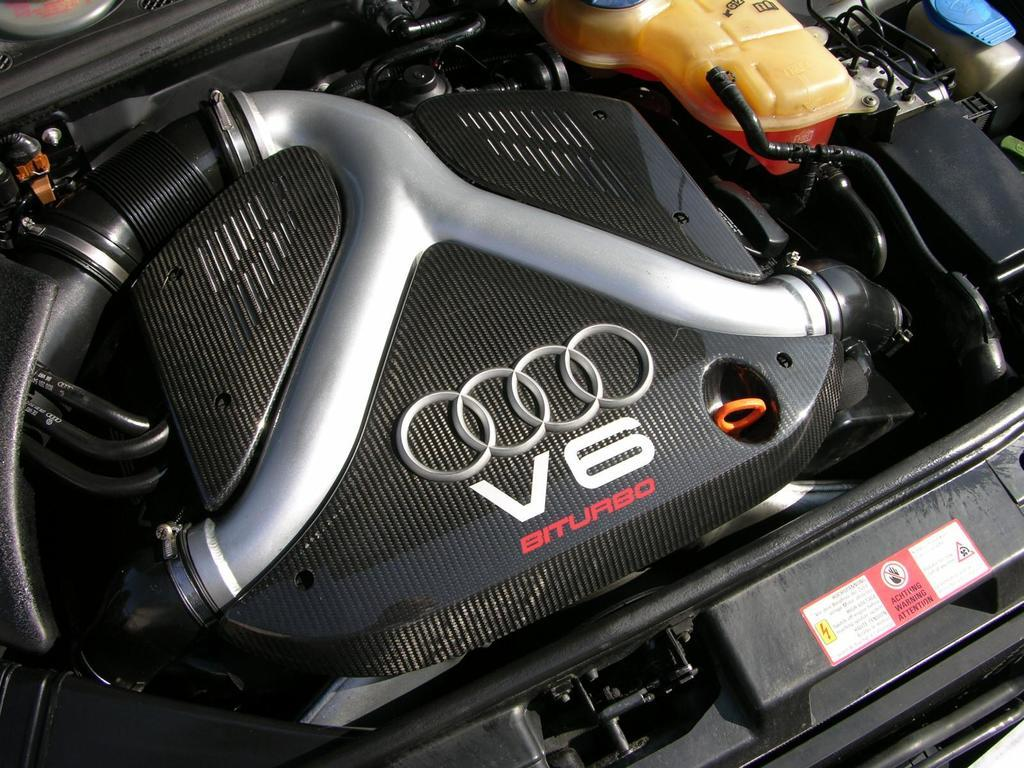What type of object is visible in the image? There are parts of a car visible in the image. What type of brush is used to clean the scarecrow in the image? There is no brush or scarecrow present in the image; it only features parts of a car. 